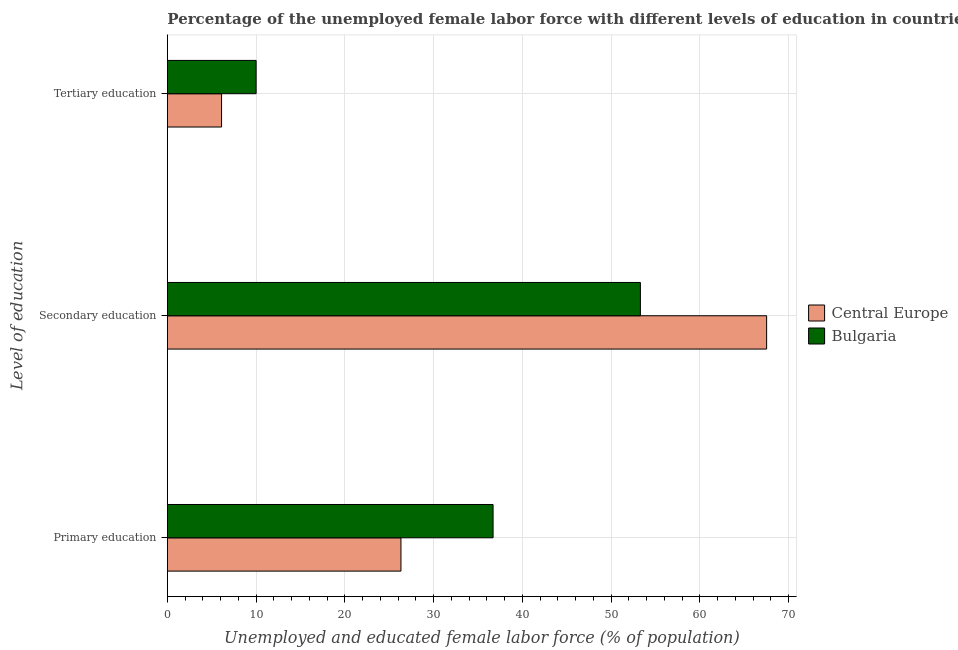How many different coloured bars are there?
Make the answer very short. 2. How many groups of bars are there?
Your answer should be very brief. 3. How many bars are there on the 2nd tick from the top?
Offer a terse response. 2. What is the percentage of female labor force who received primary education in Central Europe?
Your answer should be compact. 26.32. Across all countries, what is the maximum percentage of female labor force who received secondary education?
Ensure brevity in your answer.  67.52. Across all countries, what is the minimum percentage of female labor force who received secondary education?
Your answer should be compact. 53.3. In which country was the percentage of female labor force who received tertiary education minimum?
Keep it short and to the point. Central Europe. What is the total percentage of female labor force who received tertiary education in the graph?
Give a very brief answer. 16.11. What is the difference between the percentage of female labor force who received tertiary education in Central Europe and that in Bulgaria?
Provide a short and direct response. -3.89. What is the difference between the percentage of female labor force who received primary education in Bulgaria and the percentage of female labor force who received secondary education in Central Europe?
Keep it short and to the point. -30.82. What is the average percentage of female labor force who received secondary education per country?
Provide a succinct answer. 60.41. What is the difference between the percentage of female labor force who received primary education and percentage of female labor force who received tertiary education in Central Europe?
Offer a terse response. 20.21. In how many countries, is the percentage of female labor force who received primary education greater than 6 %?
Provide a short and direct response. 2. What is the ratio of the percentage of female labor force who received primary education in Bulgaria to that in Central Europe?
Offer a terse response. 1.39. Is the difference between the percentage of female labor force who received secondary education in Bulgaria and Central Europe greater than the difference between the percentage of female labor force who received tertiary education in Bulgaria and Central Europe?
Keep it short and to the point. No. What is the difference between the highest and the second highest percentage of female labor force who received tertiary education?
Provide a succinct answer. 3.89. What is the difference between the highest and the lowest percentage of female labor force who received primary education?
Provide a succinct answer. 10.38. In how many countries, is the percentage of female labor force who received tertiary education greater than the average percentage of female labor force who received tertiary education taken over all countries?
Make the answer very short. 1. What does the 1st bar from the top in Primary education represents?
Your answer should be very brief. Bulgaria. What does the 1st bar from the bottom in Tertiary education represents?
Your answer should be compact. Central Europe. What is the difference between two consecutive major ticks on the X-axis?
Ensure brevity in your answer.  10. What is the title of the graph?
Your answer should be compact. Percentage of the unemployed female labor force with different levels of education in countries. What is the label or title of the X-axis?
Provide a succinct answer. Unemployed and educated female labor force (% of population). What is the label or title of the Y-axis?
Make the answer very short. Level of education. What is the Unemployed and educated female labor force (% of population) in Central Europe in Primary education?
Make the answer very short. 26.32. What is the Unemployed and educated female labor force (% of population) in Bulgaria in Primary education?
Your answer should be compact. 36.7. What is the Unemployed and educated female labor force (% of population) in Central Europe in Secondary education?
Offer a very short reply. 67.52. What is the Unemployed and educated female labor force (% of population) of Bulgaria in Secondary education?
Give a very brief answer. 53.3. What is the Unemployed and educated female labor force (% of population) of Central Europe in Tertiary education?
Your answer should be compact. 6.11. What is the Unemployed and educated female labor force (% of population) in Bulgaria in Tertiary education?
Make the answer very short. 10. Across all Level of education, what is the maximum Unemployed and educated female labor force (% of population) in Central Europe?
Your answer should be very brief. 67.52. Across all Level of education, what is the maximum Unemployed and educated female labor force (% of population) in Bulgaria?
Make the answer very short. 53.3. Across all Level of education, what is the minimum Unemployed and educated female labor force (% of population) of Central Europe?
Provide a short and direct response. 6.11. What is the total Unemployed and educated female labor force (% of population) of Central Europe in the graph?
Offer a very short reply. 99.95. What is the total Unemployed and educated female labor force (% of population) of Bulgaria in the graph?
Provide a succinct answer. 100. What is the difference between the Unemployed and educated female labor force (% of population) in Central Europe in Primary education and that in Secondary education?
Your answer should be very brief. -41.21. What is the difference between the Unemployed and educated female labor force (% of population) of Bulgaria in Primary education and that in Secondary education?
Provide a short and direct response. -16.6. What is the difference between the Unemployed and educated female labor force (% of population) of Central Europe in Primary education and that in Tertiary education?
Your answer should be very brief. 20.21. What is the difference between the Unemployed and educated female labor force (% of population) in Bulgaria in Primary education and that in Tertiary education?
Ensure brevity in your answer.  26.7. What is the difference between the Unemployed and educated female labor force (% of population) of Central Europe in Secondary education and that in Tertiary education?
Provide a short and direct response. 61.42. What is the difference between the Unemployed and educated female labor force (% of population) of Bulgaria in Secondary education and that in Tertiary education?
Offer a terse response. 43.3. What is the difference between the Unemployed and educated female labor force (% of population) of Central Europe in Primary education and the Unemployed and educated female labor force (% of population) of Bulgaria in Secondary education?
Ensure brevity in your answer.  -26.98. What is the difference between the Unemployed and educated female labor force (% of population) of Central Europe in Primary education and the Unemployed and educated female labor force (% of population) of Bulgaria in Tertiary education?
Ensure brevity in your answer.  16.32. What is the difference between the Unemployed and educated female labor force (% of population) of Central Europe in Secondary education and the Unemployed and educated female labor force (% of population) of Bulgaria in Tertiary education?
Provide a succinct answer. 57.52. What is the average Unemployed and educated female labor force (% of population) of Central Europe per Level of education?
Make the answer very short. 33.32. What is the average Unemployed and educated female labor force (% of population) in Bulgaria per Level of education?
Your response must be concise. 33.33. What is the difference between the Unemployed and educated female labor force (% of population) in Central Europe and Unemployed and educated female labor force (% of population) in Bulgaria in Primary education?
Provide a short and direct response. -10.38. What is the difference between the Unemployed and educated female labor force (% of population) of Central Europe and Unemployed and educated female labor force (% of population) of Bulgaria in Secondary education?
Keep it short and to the point. 14.22. What is the difference between the Unemployed and educated female labor force (% of population) in Central Europe and Unemployed and educated female labor force (% of population) in Bulgaria in Tertiary education?
Provide a short and direct response. -3.89. What is the ratio of the Unemployed and educated female labor force (% of population) in Central Europe in Primary education to that in Secondary education?
Provide a short and direct response. 0.39. What is the ratio of the Unemployed and educated female labor force (% of population) in Bulgaria in Primary education to that in Secondary education?
Your answer should be very brief. 0.69. What is the ratio of the Unemployed and educated female labor force (% of population) of Central Europe in Primary education to that in Tertiary education?
Your answer should be very brief. 4.31. What is the ratio of the Unemployed and educated female labor force (% of population) of Bulgaria in Primary education to that in Tertiary education?
Provide a succinct answer. 3.67. What is the ratio of the Unemployed and educated female labor force (% of population) in Central Europe in Secondary education to that in Tertiary education?
Your response must be concise. 11.06. What is the ratio of the Unemployed and educated female labor force (% of population) of Bulgaria in Secondary education to that in Tertiary education?
Your response must be concise. 5.33. What is the difference between the highest and the second highest Unemployed and educated female labor force (% of population) in Central Europe?
Make the answer very short. 41.21. What is the difference between the highest and the lowest Unemployed and educated female labor force (% of population) of Central Europe?
Provide a succinct answer. 61.42. What is the difference between the highest and the lowest Unemployed and educated female labor force (% of population) in Bulgaria?
Your answer should be compact. 43.3. 